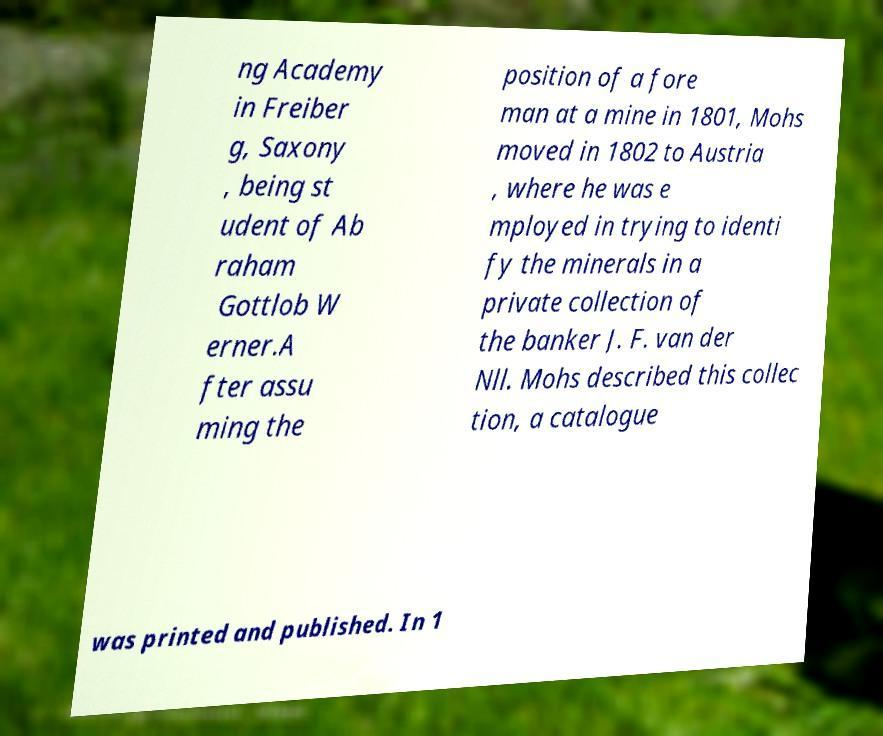Can you accurately transcribe the text from the provided image for me? ng Academy in Freiber g, Saxony , being st udent of Ab raham Gottlob W erner.A fter assu ming the position of a fore man at a mine in 1801, Mohs moved in 1802 to Austria , where he was e mployed in trying to identi fy the minerals in a private collection of the banker J. F. van der Nll. Mohs described this collec tion, a catalogue was printed and published. In 1 